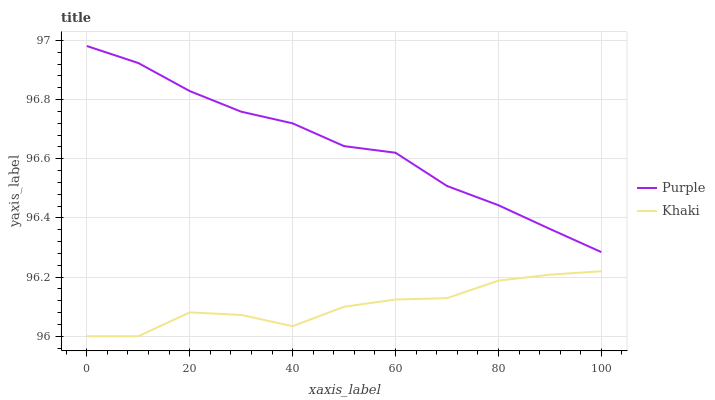Does Khaki have the minimum area under the curve?
Answer yes or no. Yes. Does Purple have the maximum area under the curve?
Answer yes or no. Yes. Does Khaki have the maximum area under the curve?
Answer yes or no. No. Is Purple the smoothest?
Answer yes or no. Yes. Is Khaki the roughest?
Answer yes or no. Yes. Is Khaki the smoothest?
Answer yes or no. No. Does Khaki have the lowest value?
Answer yes or no. Yes. Does Purple have the highest value?
Answer yes or no. Yes. Does Khaki have the highest value?
Answer yes or no. No. Is Khaki less than Purple?
Answer yes or no. Yes. Is Purple greater than Khaki?
Answer yes or no. Yes. Does Khaki intersect Purple?
Answer yes or no. No. 